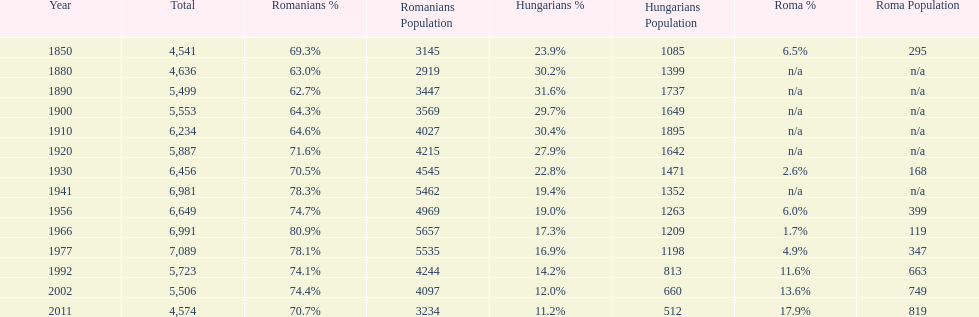In what year was there the largest percentage of hungarians? 1890. 